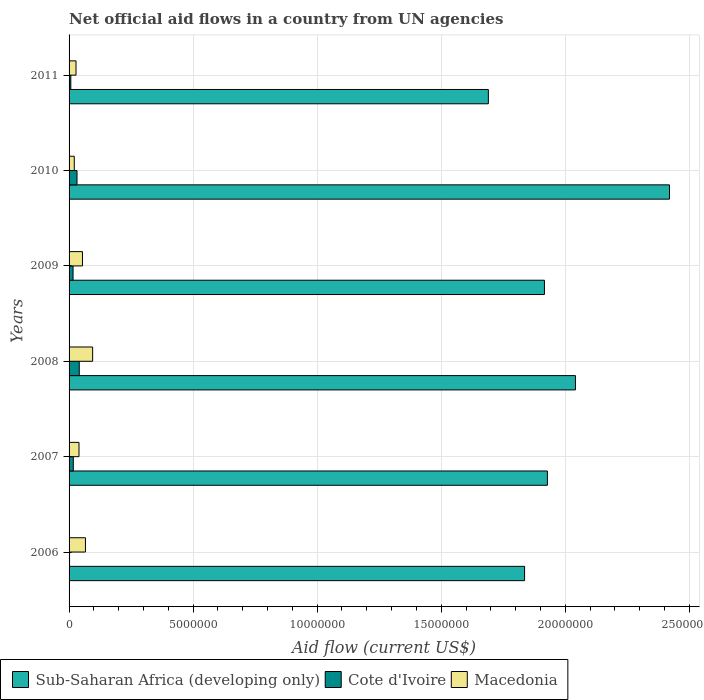How many different coloured bars are there?
Offer a terse response. 3. How many groups of bars are there?
Keep it short and to the point. 6. Are the number of bars on each tick of the Y-axis equal?
Offer a terse response. Yes. How many bars are there on the 5th tick from the top?
Make the answer very short. 3. How many bars are there on the 3rd tick from the bottom?
Ensure brevity in your answer.  3. What is the label of the 6th group of bars from the top?
Your answer should be compact. 2006. What is the net official aid flow in Cote d'Ivoire in 2008?
Offer a terse response. 4.10e+05. Across all years, what is the maximum net official aid flow in Macedonia?
Provide a short and direct response. 9.50e+05. Across all years, what is the minimum net official aid flow in Macedonia?
Make the answer very short. 2.10e+05. In which year was the net official aid flow in Sub-Saharan Africa (developing only) maximum?
Your answer should be very brief. 2010. In which year was the net official aid flow in Cote d'Ivoire minimum?
Keep it short and to the point. 2006. What is the total net official aid flow in Sub-Saharan Africa (developing only) in the graph?
Provide a short and direct response. 1.18e+08. What is the difference between the net official aid flow in Macedonia in 2009 and that in 2010?
Provide a succinct answer. 3.30e+05. What is the difference between the net official aid flow in Macedonia in 2010 and the net official aid flow in Sub-Saharan Africa (developing only) in 2008?
Offer a very short reply. -2.02e+07. What is the average net official aid flow in Cote d'Ivoire per year?
Give a very brief answer. 1.92e+05. In the year 2008, what is the difference between the net official aid flow in Macedonia and net official aid flow in Cote d'Ivoire?
Offer a very short reply. 5.40e+05. In how many years, is the net official aid flow in Sub-Saharan Africa (developing only) greater than 18000000 US$?
Your answer should be very brief. 5. What is the ratio of the net official aid flow in Cote d'Ivoire in 2008 to that in 2011?
Ensure brevity in your answer.  5.86. Is the difference between the net official aid flow in Macedonia in 2006 and 2010 greater than the difference between the net official aid flow in Cote d'Ivoire in 2006 and 2010?
Provide a succinct answer. Yes. What is the difference between the highest and the second highest net official aid flow in Sub-Saharan Africa (developing only)?
Your answer should be very brief. 3.79e+06. What is the difference between the highest and the lowest net official aid flow in Cote d'Ivoire?
Provide a succinct answer. 3.90e+05. Is the sum of the net official aid flow in Sub-Saharan Africa (developing only) in 2006 and 2008 greater than the maximum net official aid flow in Cote d'Ivoire across all years?
Ensure brevity in your answer.  Yes. What does the 3rd bar from the top in 2007 represents?
Provide a succinct answer. Sub-Saharan Africa (developing only). What does the 3rd bar from the bottom in 2010 represents?
Offer a terse response. Macedonia. Are all the bars in the graph horizontal?
Offer a very short reply. Yes. What is the difference between two consecutive major ticks on the X-axis?
Make the answer very short. 5.00e+06. Does the graph contain any zero values?
Give a very brief answer. No. Does the graph contain grids?
Your response must be concise. Yes. Where does the legend appear in the graph?
Give a very brief answer. Bottom left. How are the legend labels stacked?
Make the answer very short. Horizontal. What is the title of the graph?
Keep it short and to the point. Net official aid flows in a country from UN agencies. Does "Belarus" appear as one of the legend labels in the graph?
Keep it short and to the point. No. What is the label or title of the Y-axis?
Offer a very short reply. Years. What is the Aid flow (current US$) of Sub-Saharan Africa (developing only) in 2006?
Keep it short and to the point. 1.84e+07. What is the Aid flow (current US$) in Cote d'Ivoire in 2006?
Provide a short and direct response. 2.00e+04. What is the Aid flow (current US$) in Macedonia in 2006?
Provide a short and direct response. 6.60e+05. What is the Aid flow (current US$) of Sub-Saharan Africa (developing only) in 2007?
Your answer should be compact. 1.93e+07. What is the Aid flow (current US$) of Sub-Saharan Africa (developing only) in 2008?
Provide a succinct answer. 2.04e+07. What is the Aid flow (current US$) in Cote d'Ivoire in 2008?
Your answer should be compact. 4.10e+05. What is the Aid flow (current US$) in Macedonia in 2008?
Ensure brevity in your answer.  9.50e+05. What is the Aid flow (current US$) in Sub-Saharan Africa (developing only) in 2009?
Give a very brief answer. 1.92e+07. What is the Aid flow (current US$) in Macedonia in 2009?
Provide a short and direct response. 5.40e+05. What is the Aid flow (current US$) in Sub-Saharan Africa (developing only) in 2010?
Your response must be concise. 2.42e+07. What is the Aid flow (current US$) of Cote d'Ivoire in 2010?
Offer a very short reply. 3.20e+05. What is the Aid flow (current US$) in Macedonia in 2010?
Your response must be concise. 2.10e+05. What is the Aid flow (current US$) in Sub-Saharan Africa (developing only) in 2011?
Make the answer very short. 1.69e+07. What is the Aid flow (current US$) in Cote d'Ivoire in 2011?
Offer a very short reply. 7.00e+04. Across all years, what is the maximum Aid flow (current US$) of Sub-Saharan Africa (developing only)?
Offer a very short reply. 2.42e+07. Across all years, what is the maximum Aid flow (current US$) of Cote d'Ivoire?
Your answer should be compact. 4.10e+05. Across all years, what is the maximum Aid flow (current US$) in Macedonia?
Give a very brief answer. 9.50e+05. Across all years, what is the minimum Aid flow (current US$) in Sub-Saharan Africa (developing only)?
Give a very brief answer. 1.69e+07. What is the total Aid flow (current US$) in Sub-Saharan Africa (developing only) in the graph?
Ensure brevity in your answer.  1.18e+08. What is the total Aid flow (current US$) in Cote d'Ivoire in the graph?
Give a very brief answer. 1.15e+06. What is the total Aid flow (current US$) of Macedonia in the graph?
Your answer should be compact. 3.04e+06. What is the difference between the Aid flow (current US$) of Sub-Saharan Africa (developing only) in 2006 and that in 2007?
Give a very brief answer. -9.20e+05. What is the difference between the Aid flow (current US$) of Cote d'Ivoire in 2006 and that in 2007?
Offer a very short reply. -1.50e+05. What is the difference between the Aid flow (current US$) of Sub-Saharan Africa (developing only) in 2006 and that in 2008?
Provide a short and direct response. -2.05e+06. What is the difference between the Aid flow (current US$) of Cote d'Ivoire in 2006 and that in 2008?
Your response must be concise. -3.90e+05. What is the difference between the Aid flow (current US$) of Sub-Saharan Africa (developing only) in 2006 and that in 2009?
Your answer should be very brief. -8.00e+05. What is the difference between the Aid flow (current US$) in Macedonia in 2006 and that in 2009?
Your response must be concise. 1.20e+05. What is the difference between the Aid flow (current US$) in Sub-Saharan Africa (developing only) in 2006 and that in 2010?
Provide a short and direct response. -5.84e+06. What is the difference between the Aid flow (current US$) of Cote d'Ivoire in 2006 and that in 2010?
Make the answer very short. -3.00e+05. What is the difference between the Aid flow (current US$) in Sub-Saharan Africa (developing only) in 2006 and that in 2011?
Offer a very short reply. 1.46e+06. What is the difference between the Aid flow (current US$) in Sub-Saharan Africa (developing only) in 2007 and that in 2008?
Offer a very short reply. -1.13e+06. What is the difference between the Aid flow (current US$) in Cote d'Ivoire in 2007 and that in 2008?
Provide a short and direct response. -2.40e+05. What is the difference between the Aid flow (current US$) in Macedonia in 2007 and that in 2008?
Offer a very short reply. -5.50e+05. What is the difference between the Aid flow (current US$) of Sub-Saharan Africa (developing only) in 2007 and that in 2009?
Keep it short and to the point. 1.20e+05. What is the difference between the Aid flow (current US$) of Cote d'Ivoire in 2007 and that in 2009?
Your answer should be compact. 10000. What is the difference between the Aid flow (current US$) of Sub-Saharan Africa (developing only) in 2007 and that in 2010?
Provide a short and direct response. -4.92e+06. What is the difference between the Aid flow (current US$) of Cote d'Ivoire in 2007 and that in 2010?
Your answer should be compact. -1.50e+05. What is the difference between the Aid flow (current US$) in Sub-Saharan Africa (developing only) in 2007 and that in 2011?
Keep it short and to the point. 2.38e+06. What is the difference between the Aid flow (current US$) in Cote d'Ivoire in 2007 and that in 2011?
Offer a very short reply. 1.00e+05. What is the difference between the Aid flow (current US$) in Sub-Saharan Africa (developing only) in 2008 and that in 2009?
Your answer should be compact. 1.25e+06. What is the difference between the Aid flow (current US$) in Sub-Saharan Africa (developing only) in 2008 and that in 2010?
Make the answer very short. -3.79e+06. What is the difference between the Aid flow (current US$) in Cote d'Ivoire in 2008 and that in 2010?
Ensure brevity in your answer.  9.00e+04. What is the difference between the Aid flow (current US$) in Macedonia in 2008 and that in 2010?
Provide a succinct answer. 7.40e+05. What is the difference between the Aid flow (current US$) of Sub-Saharan Africa (developing only) in 2008 and that in 2011?
Ensure brevity in your answer.  3.51e+06. What is the difference between the Aid flow (current US$) in Macedonia in 2008 and that in 2011?
Offer a very short reply. 6.70e+05. What is the difference between the Aid flow (current US$) of Sub-Saharan Africa (developing only) in 2009 and that in 2010?
Offer a very short reply. -5.04e+06. What is the difference between the Aid flow (current US$) of Macedonia in 2009 and that in 2010?
Give a very brief answer. 3.30e+05. What is the difference between the Aid flow (current US$) in Sub-Saharan Africa (developing only) in 2009 and that in 2011?
Ensure brevity in your answer.  2.26e+06. What is the difference between the Aid flow (current US$) in Cote d'Ivoire in 2009 and that in 2011?
Provide a succinct answer. 9.00e+04. What is the difference between the Aid flow (current US$) of Macedonia in 2009 and that in 2011?
Make the answer very short. 2.60e+05. What is the difference between the Aid flow (current US$) of Sub-Saharan Africa (developing only) in 2010 and that in 2011?
Provide a short and direct response. 7.30e+06. What is the difference between the Aid flow (current US$) of Sub-Saharan Africa (developing only) in 2006 and the Aid flow (current US$) of Cote d'Ivoire in 2007?
Provide a short and direct response. 1.82e+07. What is the difference between the Aid flow (current US$) in Sub-Saharan Africa (developing only) in 2006 and the Aid flow (current US$) in Macedonia in 2007?
Ensure brevity in your answer.  1.80e+07. What is the difference between the Aid flow (current US$) of Cote d'Ivoire in 2006 and the Aid flow (current US$) of Macedonia in 2007?
Provide a succinct answer. -3.80e+05. What is the difference between the Aid flow (current US$) of Sub-Saharan Africa (developing only) in 2006 and the Aid flow (current US$) of Cote d'Ivoire in 2008?
Provide a short and direct response. 1.80e+07. What is the difference between the Aid flow (current US$) of Sub-Saharan Africa (developing only) in 2006 and the Aid flow (current US$) of Macedonia in 2008?
Provide a short and direct response. 1.74e+07. What is the difference between the Aid flow (current US$) of Cote d'Ivoire in 2006 and the Aid flow (current US$) of Macedonia in 2008?
Make the answer very short. -9.30e+05. What is the difference between the Aid flow (current US$) of Sub-Saharan Africa (developing only) in 2006 and the Aid flow (current US$) of Cote d'Ivoire in 2009?
Keep it short and to the point. 1.82e+07. What is the difference between the Aid flow (current US$) of Sub-Saharan Africa (developing only) in 2006 and the Aid flow (current US$) of Macedonia in 2009?
Provide a short and direct response. 1.78e+07. What is the difference between the Aid flow (current US$) in Cote d'Ivoire in 2006 and the Aid flow (current US$) in Macedonia in 2009?
Your answer should be very brief. -5.20e+05. What is the difference between the Aid flow (current US$) of Sub-Saharan Africa (developing only) in 2006 and the Aid flow (current US$) of Cote d'Ivoire in 2010?
Ensure brevity in your answer.  1.80e+07. What is the difference between the Aid flow (current US$) of Sub-Saharan Africa (developing only) in 2006 and the Aid flow (current US$) of Macedonia in 2010?
Make the answer very short. 1.82e+07. What is the difference between the Aid flow (current US$) of Cote d'Ivoire in 2006 and the Aid flow (current US$) of Macedonia in 2010?
Give a very brief answer. -1.90e+05. What is the difference between the Aid flow (current US$) of Sub-Saharan Africa (developing only) in 2006 and the Aid flow (current US$) of Cote d'Ivoire in 2011?
Your answer should be compact. 1.83e+07. What is the difference between the Aid flow (current US$) in Sub-Saharan Africa (developing only) in 2006 and the Aid flow (current US$) in Macedonia in 2011?
Your answer should be compact. 1.81e+07. What is the difference between the Aid flow (current US$) of Sub-Saharan Africa (developing only) in 2007 and the Aid flow (current US$) of Cote d'Ivoire in 2008?
Keep it short and to the point. 1.89e+07. What is the difference between the Aid flow (current US$) in Sub-Saharan Africa (developing only) in 2007 and the Aid flow (current US$) in Macedonia in 2008?
Your answer should be very brief. 1.83e+07. What is the difference between the Aid flow (current US$) in Cote d'Ivoire in 2007 and the Aid flow (current US$) in Macedonia in 2008?
Make the answer very short. -7.80e+05. What is the difference between the Aid flow (current US$) of Sub-Saharan Africa (developing only) in 2007 and the Aid flow (current US$) of Cote d'Ivoire in 2009?
Keep it short and to the point. 1.91e+07. What is the difference between the Aid flow (current US$) in Sub-Saharan Africa (developing only) in 2007 and the Aid flow (current US$) in Macedonia in 2009?
Offer a terse response. 1.87e+07. What is the difference between the Aid flow (current US$) in Cote d'Ivoire in 2007 and the Aid flow (current US$) in Macedonia in 2009?
Offer a very short reply. -3.70e+05. What is the difference between the Aid flow (current US$) in Sub-Saharan Africa (developing only) in 2007 and the Aid flow (current US$) in Cote d'Ivoire in 2010?
Give a very brief answer. 1.90e+07. What is the difference between the Aid flow (current US$) in Sub-Saharan Africa (developing only) in 2007 and the Aid flow (current US$) in Macedonia in 2010?
Your answer should be compact. 1.91e+07. What is the difference between the Aid flow (current US$) of Cote d'Ivoire in 2007 and the Aid flow (current US$) of Macedonia in 2010?
Offer a very short reply. -4.00e+04. What is the difference between the Aid flow (current US$) in Sub-Saharan Africa (developing only) in 2007 and the Aid flow (current US$) in Cote d'Ivoire in 2011?
Provide a short and direct response. 1.92e+07. What is the difference between the Aid flow (current US$) in Sub-Saharan Africa (developing only) in 2007 and the Aid flow (current US$) in Macedonia in 2011?
Your answer should be very brief. 1.90e+07. What is the difference between the Aid flow (current US$) in Cote d'Ivoire in 2007 and the Aid flow (current US$) in Macedonia in 2011?
Make the answer very short. -1.10e+05. What is the difference between the Aid flow (current US$) of Sub-Saharan Africa (developing only) in 2008 and the Aid flow (current US$) of Cote d'Ivoire in 2009?
Your answer should be very brief. 2.02e+07. What is the difference between the Aid flow (current US$) in Sub-Saharan Africa (developing only) in 2008 and the Aid flow (current US$) in Macedonia in 2009?
Ensure brevity in your answer.  1.99e+07. What is the difference between the Aid flow (current US$) in Sub-Saharan Africa (developing only) in 2008 and the Aid flow (current US$) in Cote d'Ivoire in 2010?
Offer a terse response. 2.01e+07. What is the difference between the Aid flow (current US$) of Sub-Saharan Africa (developing only) in 2008 and the Aid flow (current US$) of Macedonia in 2010?
Offer a very short reply. 2.02e+07. What is the difference between the Aid flow (current US$) of Sub-Saharan Africa (developing only) in 2008 and the Aid flow (current US$) of Cote d'Ivoire in 2011?
Offer a very short reply. 2.03e+07. What is the difference between the Aid flow (current US$) in Sub-Saharan Africa (developing only) in 2008 and the Aid flow (current US$) in Macedonia in 2011?
Keep it short and to the point. 2.01e+07. What is the difference between the Aid flow (current US$) of Sub-Saharan Africa (developing only) in 2009 and the Aid flow (current US$) of Cote d'Ivoire in 2010?
Your answer should be compact. 1.88e+07. What is the difference between the Aid flow (current US$) of Sub-Saharan Africa (developing only) in 2009 and the Aid flow (current US$) of Macedonia in 2010?
Offer a very short reply. 1.90e+07. What is the difference between the Aid flow (current US$) in Sub-Saharan Africa (developing only) in 2009 and the Aid flow (current US$) in Cote d'Ivoire in 2011?
Provide a short and direct response. 1.91e+07. What is the difference between the Aid flow (current US$) of Sub-Saharan Africa (developing only) in 2009 and the Aid flow (current US$) of Macedonia in 2011?
Provide a succinct answer. 1.89e+07. What is the difference between the Aid flow (current US$) of Sub-Saharan Africa (developing only) in 2010 and the Aid flow (current US$) of Cote d'Ivoire in 2011?
Your answer should be very brief. 2.41e+07. What is the difference between the Aid flow (current US$) in Sub-Saharan Africa (developing only) in 2010 and the Aid flow (current US$) in Macedonia in 2011?
Offer a terse response. 2.39e+07. What is the average Aid flow (current US$) in Sub-Saharan Africa (developing only) per year?
Provide a short and direct response. 1.97e+07. What is the average Aid flow (current US$) in Cote d'Ivoire per year?
Provide a succinct answer. 1.92e+05. What is the average Aid flow (current US$) of Macedonia per year?
Give a very brief answer. 5.07e+05. In the year 2006, what is the difference between the Aid flow (current US$) in Sub-Saharan Africa (developing only) and Aid flow (current US$) in Cote d'Ivoire?
Keep it short and to the point. 1.83e+07. In the year 2006, what is the difference between the Aid flow (current US$) of Sub-Saharan Africa (developing only) and Aid flow (current US$) of Macedonia?
Keep it short and to the point. 1.77e+07. In the year 2006, what is the difference between the Aid flow (current US$) in Cote d'Ivoire and Aid flow (current US$) in Macedonia?
Give a very brief answer. -6.40e+05. In the year 2007, what is the difference between the Aid flow (current US$) of Sub-Saharan Africa (developing only) and Aid flow (current US$) of Cote d'Ivoire?
Keep it short and to the point. 1.91e+07. In the year 2007, what is the difference between the Aid flow (current US$) of Sub-Saharan Africa (developing only) and Aid flow (current US$) of Macedonia?
Provide a short and direct response. 1.89e+07. In the year 2007, what is the difference between the Aid flow (current US$) of Cote d'Ivoire and Aid flow (current US$) of Macedonia?
Your answer should be compact. -2.30e+05. In the year 2008, what is the difference between the Aid flow (current US$) in Sub-Saharan Africa (developing only) and Aid flow (current US$) in Cote d'Ivoire?
Provide a succinct answer. 2.00e+07. In the year 2008, what is the difference between the Aid flow (current US$) in Sub-Saharan Africa (developing only) and Aid flow (current US$) in Macedonia?
Your response must be concise. 1.95e+07. In the year 2008, what is the difference between the Aid flow (current US$) of Cote d'Ivoire and Aid flow (current US$) of Macedonia?
Keep it short and to the point. -5.40e+05. In the year 2009, what is the difference between the Aid flow (current US$) in Sub-Saharan Africa (developing only) and Aid flow (current US$) in Cote d'Ivoire?
Offer a very short reply. 1.90e+07. In the year 2009, what is the difference between the Aid flow (current US$) of Sub-Saharan Africa (developing only) and Aid flow (current US$) of Macedonia?
Offer a terse response. 1.86e+07. In the year 2009, what is the difference between the Aid flow (current US$) of Cote d'Ivoire and Aid flow (current US$) of Macedonia?
Your response must be concise. -3.80e+05. In the year 2010, what is the difference between the Aid flow (current US$) in Sub-Saharan Africa (developing only) and Aid flow (current US$) in Cote d'Ivoire?
Your response must be concise. 2.39e+07. In the year 2010, what is the difference between the Aid flow (current US$) of Sub-Saharan Africa (developing only) and Aid flow (current US$) of Macedonia?
Give a very brief answer. 2.40e+07. In the year 2010, what is the difference between the Aid flow (current US$) of Cote d'Ivoire and Aid flow (current US$) of Macedonia?
Make the answer very short. 1.10e+05. In the year 2011, what is the difference between the Aid flow (current US$) in Sub-Saharan Africa (developing only) and Aid flow (current US$) in Cote d'Ivoire?
Your answer should be compact. 1.68e+07. In the year 2011, what is the difference between the Aid flow (current US$) in Sub-Saharan Africa (developing only) and Aid flow (current US$) in Macedonia?
Your answer should be very brief. 1.66e+07. What is the ratio of the Aid flow (current US$) in Sub-Saharan Africa (developing only) in 2006 to that in 2007?
Offer a terse response. 0.95. What is the ratio of the Aid flow (current US$) in Cote d'Ivoire in 2006 to that in 2007?
Your response must be concise. 0.12. What is the ratio of the Aid flow (current US$) in Macedonia in 2006 to that in 2007?
Keep it short and to the point. 1.65. What is the ratio of the Aid flow (current US$) of Sub-Saharan Africa (developing only) in 2006 to that in 2008?
Offer a terse response. 0.9. What is the ratio of the Aid flow (current US$) in Cote d'Ivoire in 2006 to that in 2008?
Your answer should be compact. 0.05. What is the ratio of the Aid flow (current US$) in Macedonia in 2006 to that in 2008?
Provide a succinct answer. 0.69. What is the ratio of the Aid flow (current US$) of Sub-Saharan Africa (developing only) in 2006 to that in 2009?
Provide a short and direct response. 0.96. What is the ratio of the Aid flow (current US$) in Cote d'Ivoire in 2006 to that in 2009?
Ensure brevity in your answer.  0.12. What is the ratio of the Aid flow (current US$) of Macedonia in 2006 to that in 2009?
Ensure brevity in your answer.  1.22. What is the ratio of the Aid flow (current US$) of Sub-Saharan Africa (developing only) in 2006 to that in 2010?
Provide a succinct answer. 0.76. What is the ratio of the Aid flow (current US$) in Cote d'Ivoire in 2006 to that in 2010?
Offer a terse response. 0.06. What is the ratio of the Aid flow (current US$) in Macedonia in 2006 to that in 2010?
Make the answer very short. 3.14. What is the ratio of the Aid flow (current US$) in Sub-Saharan Africa (developing only) in 2006 to that in 2011?
Keep it short and to the point. 1.09. What is the ratio of the Aid flow (current US$) of Cote d'Ivoire in 2006 to that in 2011?
Keep it short and to the point. 0.29. What is the ratio of the Aid flow (current US$) in Macedonia in 2006 to that in 2011?
Provide a short and direct response. 2.36. What is the ratio of the Aid flow (current US$) in Sub-Saharan Africa (developing only) in 2007 to that in 2008?
Offer a very short reply. 0.94. What is the ratio of the Aid flow (current US$) in Cote d'Ivoire in 2007 to that in 2008?
Keep it short and to the point. 0.41. What is the ratio of the Aid flow (current US$) of Macedonia in 2007 to that in 2008?
Your answer should be very brief. 0.42. What is the ratio of the Aid flow (current US$) of Cote d'Ivoire in 2007 to that in 2009?
Offer a very short reply. 1.06. What is the ratio of the Aid flow (current US$) in Macedonia in 2007 to that in 2009?
Your answer should be very brief. 0.74. What is the ratio of the Aid flow (current US$) in Sub-Saharan Africa (developing only) in 2007 to that in 2010?
Make the answer very short. 0.8. What is the ratio of the Aid flow (current US$) of Cote d'Ivoire in 2007 to that in 2010?
Keep it short and to the point. 0.53. What is the ratio of the Aid flow (current US$) of Macedonia in 2007 to that in 2010?
Offer a very short reply. 1.9. What is the ratio of the Aid flow (current US$) in Sub-Saharan Africa (developing only) in 2007 to that in 2011?
Ensure brevity in your answer.  1.14. What is the ratio of the Aid flow (current US$) in Cote d'Ivoire in 2007 to that in 2011?
Provide a succinct answer. 2.43. What is the ratio of the Aid flow (current US$) of Macedonia in 2007 to that in 2011?
Give a very brief answer. 1.43. What is the ratio of the Aid flow (current US$) in Sub-Saharan Africa (developing only) in 2008 to that in 2009?
Your answer should be compact. 1.07. What is the ratio of the Aid flow (current US$) of Cote d'Ivoire in 2008 to that in 2009?
Give a very brief answer. 2.56. What is the ratio of the Aid flow (current US$) in Macedonia in 2008 to that in 2009?
Provide a succinct answer. 1.76. What is the ratio of the Aid flow (current US$) in Sub-Saharan Africa (developing only) in 2008 to that in 2010?
Provide a succinct answer. 0.84. What is the ratio of the Aid flow (current US$) of Cote d'Ivoire in 2008 to that in 2010?
Provide a short and direct response. 1.28. What is the ratio of the Aid flow (current US$) in Macedonia in 2008 to that in 2010?
Provide a succinct answer. 4.52. What is the ratio of the Aid flow (current US$) of Sub-Saharan Africa (developing only) in 2008 to that in 2011?
Your answer should be compact. 1.21. What is the ratio of the Aid flow (current US$) of Cote d'Ivoire in 2008 to that in 2011?
Provide a succinct answer. 5.86. What is the ratio of the Aid flow (current US$) of Macedonia in 2008 to that in 2011?
Ensure brevity in your answer.  3.39. What is the ratio of the Aid flow (current US$) of Sub-Saharan Africa (developing only) in 2009 to that in 2010?
Your answer should be compact. 0.79. What is the ratio of the Aid flow (current US$) of Macedonia in 2009 to that in 2010?
Keep it short and to the point. 2.57. What is the ratio of the Aid flow (current US$) of Sub-Saharan Africa (developing only) in 2009 to that in 2011?
Offer a terse response. 1.13. What is the ratio of the Aid flow (current US$) of Cote d'Ivoire in 2009 to that in 2011?
Ensure brevity in your answer.  2.29. What is the ratio of the Aid flow (current US$) in Macedonia in 2009 to that in 2011?
Provide a short and direct response. 1.93. What is the ratio of the Aid flow (current US$) of Sub-Saharan Africa (developing only) in 2010 to that in 2011?
Offer a terse response. 1.43. What is the ratio of the Aid flow (current US$) in Cote d'Ivoire in 2010 to that in 2011?
Offer a terse response. 4.57. What is the ratio of the Aid flow (current US$) of Macedonia in 2010 to that in 2011?
Offer a very short reply. 0.75. What is the difference between the highest and the second highest Aid flow (current US$) in Sub-Saharan Africa (developing only)?
Keep it short and to the point. 3.79e+06. What is the difference between the highest and the second highest Aid flow (current US$) of Cote d'Ivoire?
Provide a succinct answer. 9.00e+04. What is the difference between the highest and the lowest Aid flow (current US$) in Sub-Saharan Africa (developing only)?
Provide a succinct answer. 7.30e+06. What is the difference between the highest and the lowest Aid flow (current US$) in Cote d'Ivoire?
Provide a succinct answer. 3.90e+05. What is the difference between the highest and the lowest Aid flow (current US$) of Macedonia?
Ensure brevity in your answer.  7.40e+05. 